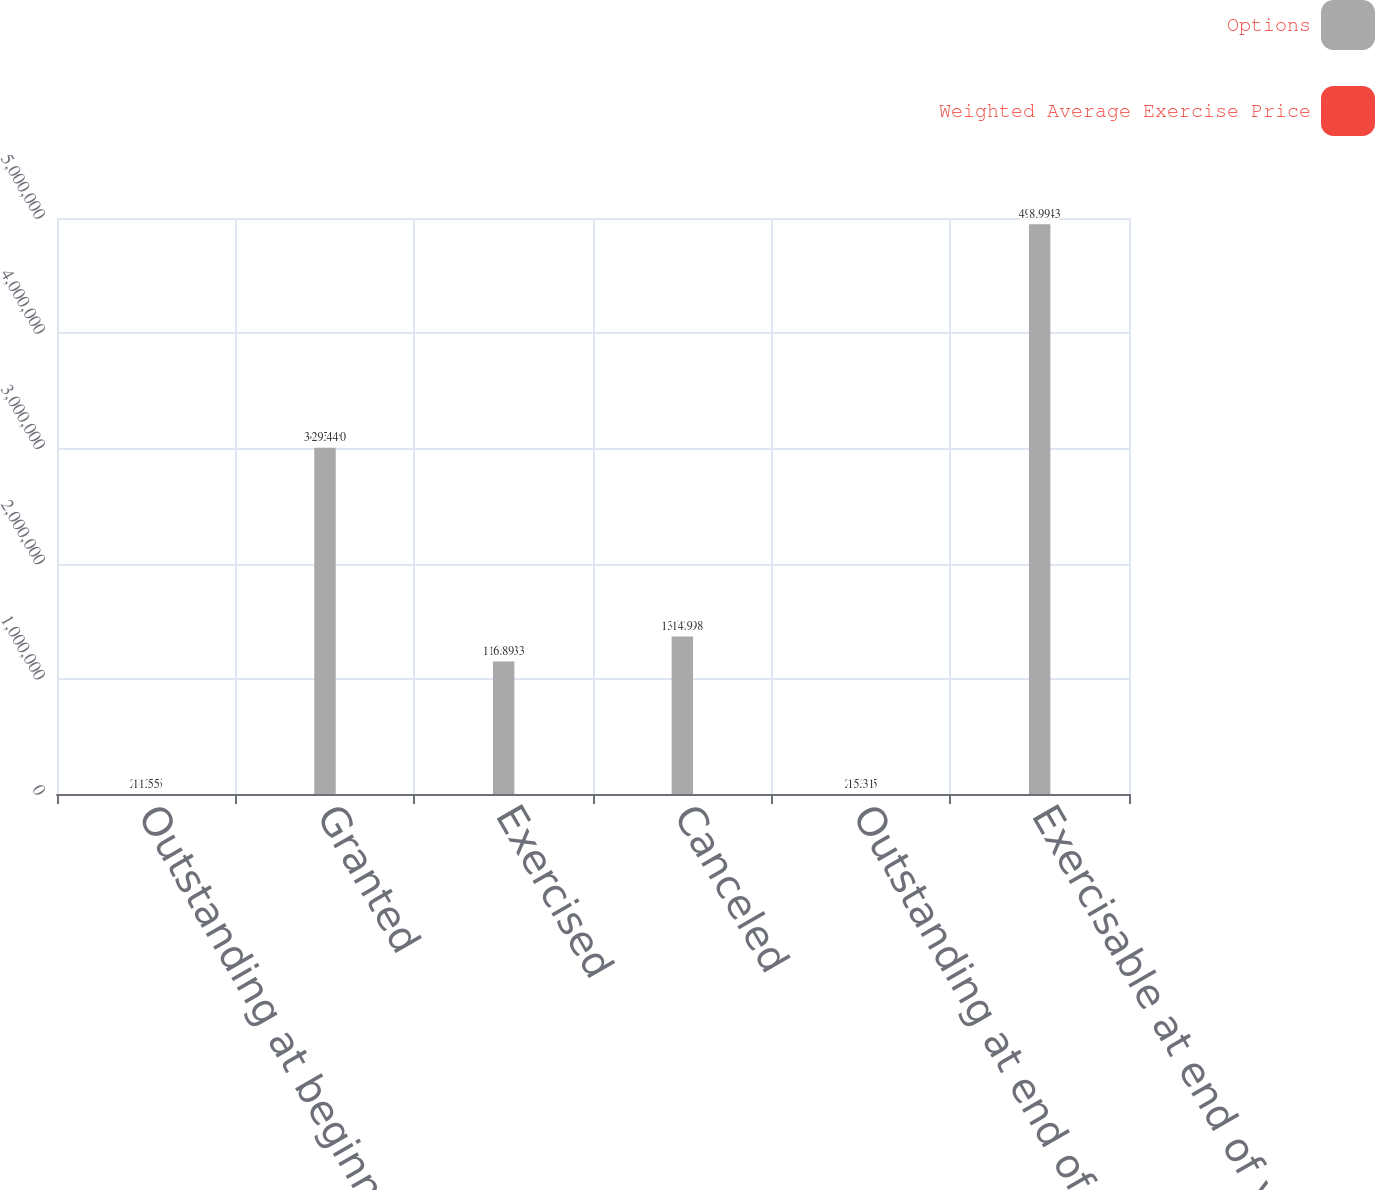<chart> <loc_0><loc_0><loc_500><loc_500><stacked_bar_chart><ecel><fcel>Outstanding at beginning of<fcel>Granted<fcel>Exercised<fcel>Canceled<fcel>Outstanding at end of year<fcel>Exercisable at end of year<nl><fcel>Options<fcel>22.375<fcel>3.0055e+06<fcel>1.14943e+06<fcel>1.368e+06<fcel>22.375<fcel>4.94554e+06<nl><fcel>Weighted Average Exercise Price<fcel>11.55<fcel>29.44<fcel>6.89<fcel>14.9<fcel>15.31<fcel>8.99<nl></chart> 